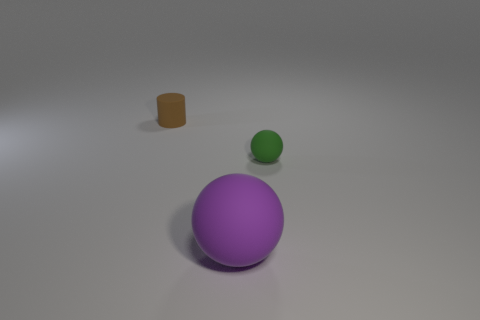Add 3 big brown cubes. How many objects exist? 6 Subtract all cylinders. How many objects are left? 2 Subtract 0 blue cylinders. How many objects are left? 3 Subtract all large cyan rubber cylinders. Subtract all tiny brown cylinders. How many objects are left? 2 Add 2 green balls. How many green balls are left? 3 Add 2 brown metallic cylinders. How many brown metallic cylinders exist? 2 